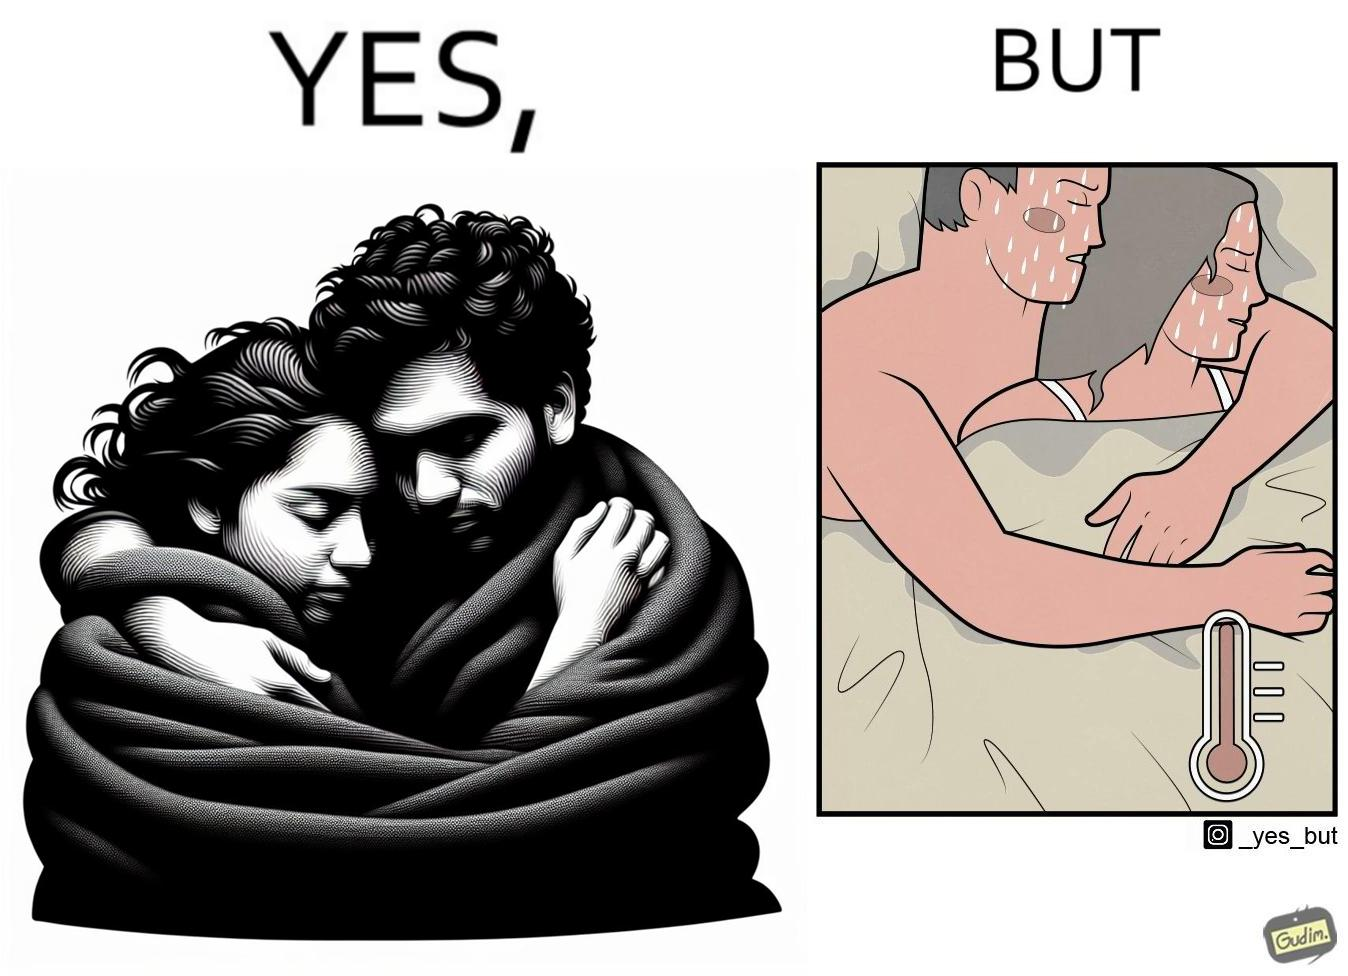Describe what you see in this image. The image is ironic, because after some time cuddling within a blanket raises the temperature which leads to inconvenience 